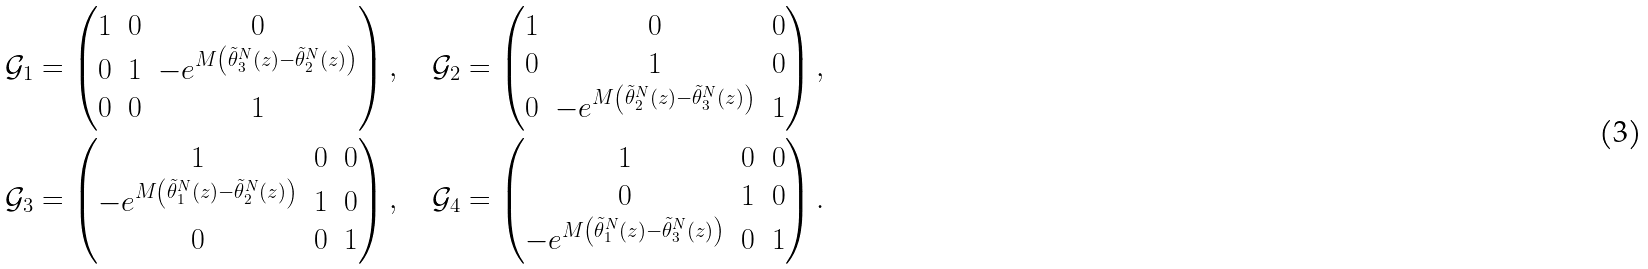Convert formula to latex. <formula><loc_0><loc_0><loc_500><loc_500>\mathcal { G } _ { 1 } & = \begin{pmatrix} 1 & 0 & 0 \\ 0 & 1 & - e ^ { M \left ( \tilde { \theta } _ { 3 } ^ { N } ( z ) - \tilde { \theta } _ { 2 } ^ { N } ( z ) \right ) } \\ 0 & 0 & 1 \end{pmatrix} , \quad \mathcal { G } _ { 2 } = \begin{pmatrix} 1 & 0 & 0 \\ 0 & 1 & 0 \\ 0 & - e ^ { M \left ( \tilde { \theta } _ { 2 } ^ { N } ( z ) - \tilde { \theta } _ { 3 } ^ { N } ( z ) \right ) } & 1 \end{pmatrix} , \\ \mathcal { G } _ { 3 } & = \begin{pmatrix} 1 & 0 & 0 \\ - e ^ { M \left ( \tilde { \theta } _ { 1 } ^ { N } ( z ) - \tilde { \theta } _ { 2 } ^ { N } ( z ) \right ) } & 1 & 0 \\ 0 & 0 & 1 \end{pmatrix} , \quad \mathcal { G } _ { 4 } = \begin{pmatrix} 1 & 0 & 0 \\ 0 & 1 & 0 \\ - e ^ { M \left ( \tilde { \theta } _ { 1 } ^ { N } ( z ) - \tilde { \theta } _ { 3 } ^ { N } ( z ) \right ) } & 0 & 1 \end{pmatrix} .</formula> 